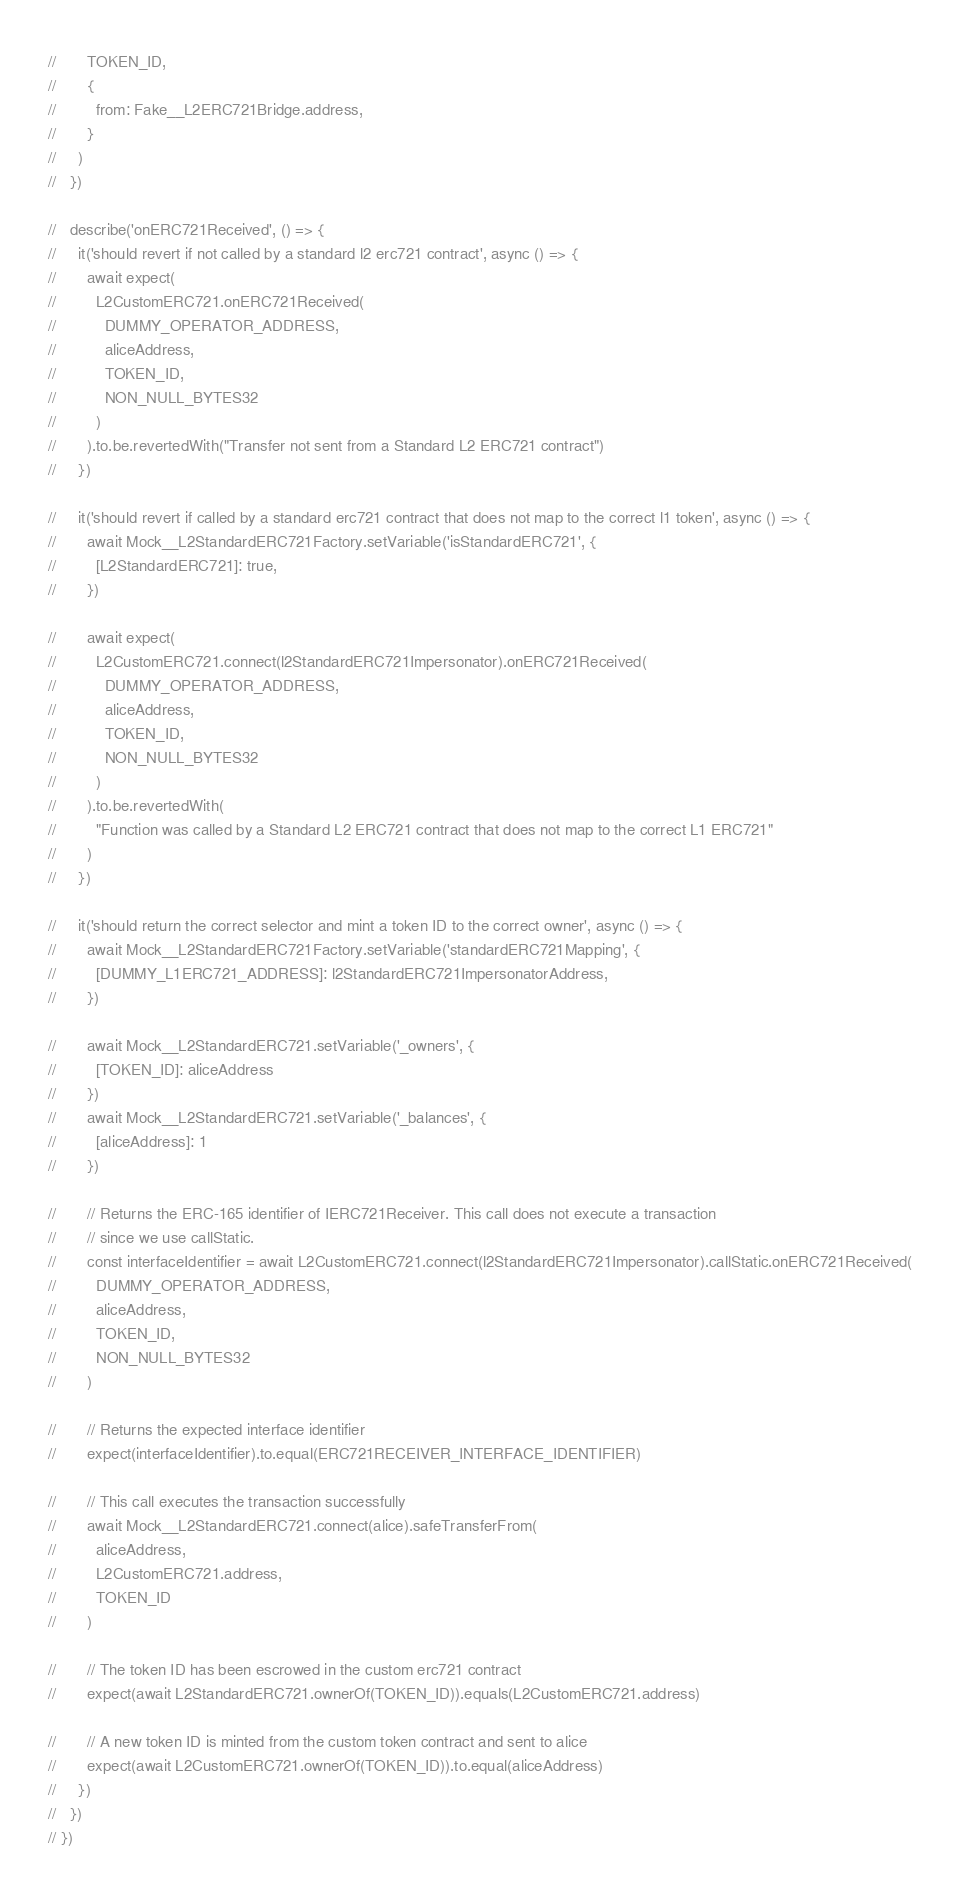Convert code to text. <code><loc_0><loc_0><loc_500><loc_500><_TypeScript_>//       TOKEN_ID,
//       {
//         from: Fake__L2ERC721Bridge.address,
//       }
//     )
//   })

//   describe('onERC721Received', () => {
//     it('should revert if not called by a standard l2 erc721 contract', async () => {
//       await expect(
//         L2CustomERC721.onERC721Received(
//           DUMMY_OPERATOR_ADDRESS,
//           aliceAddress,
//           TOKEN_ID,
//           NON_NULL_BYTES32
//         )
//       ).to.be.revertedWith("Transfer not sent from a Standard L2 ERC721 contract")
//     })

//     it('should revert if called by a standard erc721 contract that does not map to the correct l1 token', async () => {
//       await Mock__L2StandardERC721Factory.setVariable('isStandardERC721', {
//         [L2StandardERC721]: true,
//       })

//       await expect(
//         L2CustomERC721.connect(l2StandardERC721Impersonator).onERC721Received(
//           DUMMY_OPERATOR_ADDRESS,
//           aliceAddress,
//           TOKEN_ID,
//           NON_NULL_BYTES32
//         )
//       ).to.be.revertedWith(
//         "Function was called by a Standard L2 ERC721 contract that does not map to the correct L1 ERC721"
//       )
//     })

//     it('should return the correct selector and mint a token ID to the correct owner', async () => {
//       await Mock__L2StandardERC721Factory.setVariable('standardERC721Mapping', {
//         [DUMMY_L1ERC721_ADDRESS]: l2StandardERC721ImpersonatorAddress,
//       })

//       await Mock__L2StandardERC721.setVariable('_owners', {
//         [TOKEN_ID]: aliceAddress
//       })
//       await Mock__L2StandardERC721.setVariable('_balances', {
//         [aliceAddress]: 1
//       })

//       // Returns the ERC-165 identifier of IERC721Receiver. This call does not execute a transaction
//       // since we use callStatic.
//       const interfaceIdentifier = await L2CustomERC721.connect(l2StandardERC721Impersonator).callStatic.onERC721Received(
//         DUMMY_OPERATOR_ADDRESS,
//         aliceAddress,
//         TOKEN_ID,
//         NON_NULL_BYTES32
//       )

//       // Returns the expected interface identifier
//       expect(interfaceIdentifier).to.equal(ERC721RECEIVER_INTERFACE_IDENTIFIER)

//       // This call executes the transaction successfully
//       await Mock__L2StandardERC721.connect(alice).safeTransferFrom(
//         aliceAddress,
//         L2CustomERC721.address,
//         TOKEN_ID
//       )

//       // The token ID has been escrowed in the custom erc721 contract
//       expect(await L2StandardERC721.ownerOf(TOKEN_ID)).equals(L2CustomERC721.address)

//       // A new token ID is minted from the custom token contract and sent to alice
//       expect(await L2CustomERC721.ownerOf(TOKEN_ID)).to.equal(aliceAddress)
//     })
//   })
// })
</code> 